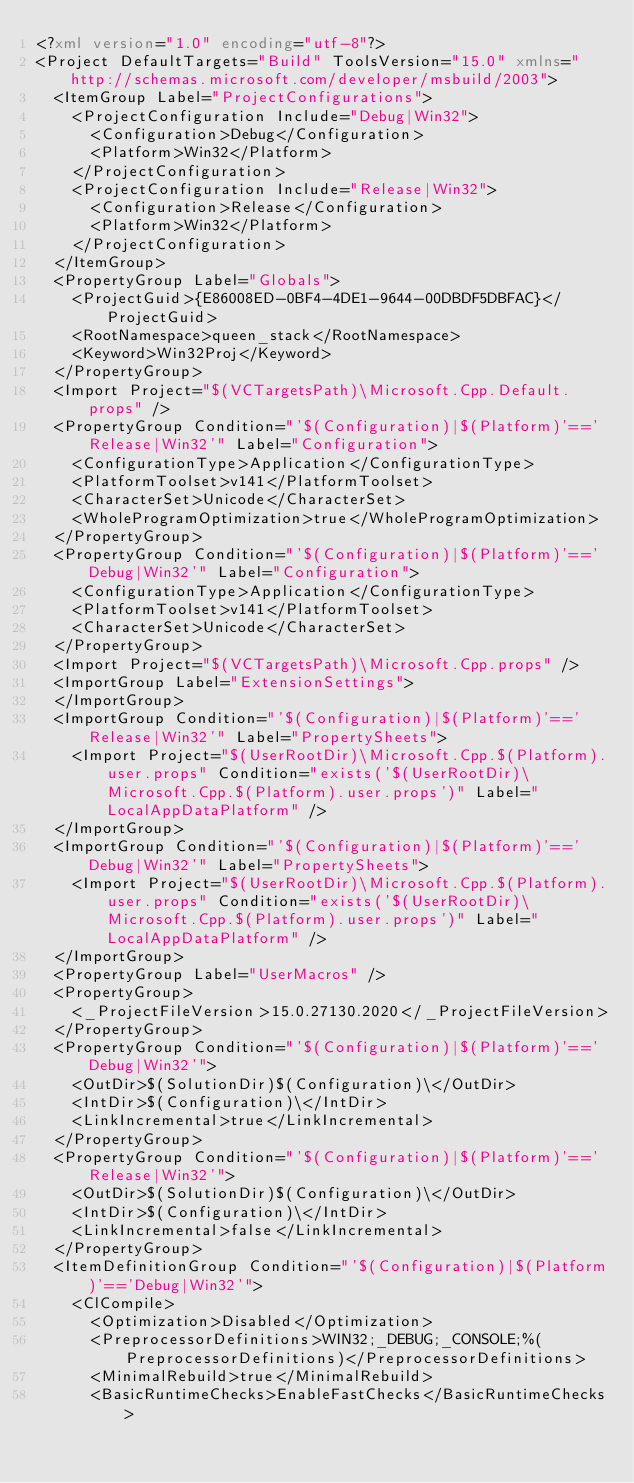Convert code to text. <code><loc_0><loc_0><loc_500><loc_500><_XML_><?xml version="1.0" encoding="utf-8"?>
<Project DefaultTargets="Build" ToolsVersion="15.0" xmlns="http://schemas.microsoft.com/developer/msbuild/2003">
  <ItemGroup Label="ProjectConfigurations">
    <ProjectConfiguration Include="Debug|Win32">
      <Configuration>Debug</Configuration>
      <Platform>Win32</Platform>
    </ProjectConfiguration>
    <ProjectConfiguration Include="Release|Win32">
      <Configuration>Release</Configuration>
      <Platform>Win32</Platform>
    </ProjectConfiguration>
  </ItemGroup>
  <PropertyGroup Label="Globals">
    <ProjectGuid>{E86008ED-0BF4-4DE1-9644-00DBDF5DBFAC}</ProjectGuid>
    <RootNamespace>queen_stack</RootNamespace>
    <Keyword>Win32Proj</Keyword>
  </PropertyGroup>
  <Import Project="$(VCTargetsPath)\Microsoft.Cpp.Default.props" />
  <PropertyGroup Condition="'$(Configuration)|$(Platform)'=='Release|Win32'" Label="Configuration">
    <ConfigurationType>Application</ConfigurationType>
    <PlatformToolset>v141</PlatformToolset>
    <CharacterSet>Unicode</CharacterSet>
    <WholeProgramOptimization>true</WholeProgramOptimization>
  </PropertyGroup>
  <PropertyGroup Condition="'$(Configuration)|$(Platform)'=='Debug|Win32'" Label="Configuration">
    <ConfigurationType>Application</ConfigurationType>
    <PlatformToolset>v141</PlatformToolset>
    <CharacterSet>Unicode</CharacterSet>
  </PropertyGroup>
  <Import Project="$(VCTargetsPath)\Microsoft.Cpp.props" />
  <ImportGroup Label="ExtensionSettings">
  </ImportGroup>
  <ImportGroup Condition="'$(Configuration)|$(Platform)'=='Release|Win32'" Label="PropertySheets">
    <Import Project="$(UserRootDir)\Microsoft.Cpp.$(Platform).user.props" Condition="exists('$(UserRootDir)\Microsoft.Cpp.$(Platform).user.props')" Label="LocalAppDataPlatform" />
  </ImportGroup>
  <ImportGroup Condition="'$(Configuration)|$(Platform)'=='Debug|Win32'" Label="PropertySheets">
    <Import Project="$(UserRootDir)\Microsoft.Cpp.$(Platform).user.props" Condition="exists('$(UserRootDir)\Microsoft.Cpp.$(Platform).user.props')" Label="LocalAppDataPlatform" />
  </ImportGroup>
  <PropertyGroup Label="UserMacros" />
  <PropertyGroup>
    <_ProjectFileVersion>15.0.27130.2020</_ProjectFileVersion>
  </PropertyGroup>
  <PropertyGroup Condition="'$(Configuration)|$(Platform)'=='Debug|Win32'">
    <OutDir>$(SolutionDir)$(Configuration)\</OutDir>
    <IntDir>$(Configuration)\</IntDir>
    <LinkIncremental>true</LinkIncremental>
  </PropertyGroup>
  <PropertyGroup Condition="'$(Configuration)|$(Platform)'=='Release|Win32'">
    <OutDir>$(SolutionDir)$(Configuration)\</OutDir>
    <IntDir>$(Configuration)\</IntDir>
    <LinkIncremental>false</LinkIncremental>
  </PropertyGroup>
  <ItemDefinitionGroup Condition="'$(Configuration)|$(Platform)'=='Debug|Win32'">
    <ClCompile>
      <Optimization>Disabled</Optimization>
      <PreprocessorDefinitions>WIN32;_DEBUG;_CONSOLE;%(PreprocessorDefinitions)</PreprocessorDefinitions>
      <MinimalRebuild>true</MinimalRebuild>
      <BasicRuntimeChecks>EnableFastChecks</BasicRuntimeChecks></code> 